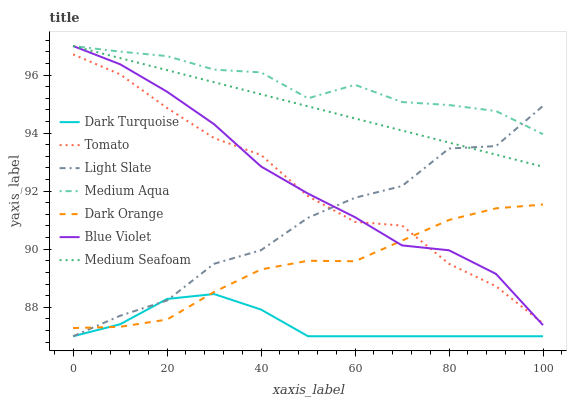Does Dark Turquoise have the minimum area under the curve?
Answer yes or no. Yes. Does Medium Aqua have the maximum area under the curve?
Answer yes or no. Yes. Does Dark Orange have the minimum area under the curve?
Answer yes or no. No. Does Dark Orange have the maximum area under the curve?
Answer yes or no. No. Is Medium Seafoam the smoothest?
Answer yes or no. Yes. Is Light Slate the roughest?
Answer yes or no. Yes. Is Dark Orange the smoothest?
Answer yes or no. No. Is Dark Orange the roughest?
Answer yes or no. No. Does Dark Orange have the lowest value?
Answer yes or no. No. Does Blue Violet have the highest value?
Answer yes or no. Yes. Does Dark Orange have the highest value?
Answer yes or no. No. Is Dark Orange less than Medium Seafoam?
Answer yes or no. Yes. Is Medium Seafoam greater than Dark Turquoise?
Answer yes or no. Yes. Does Light Slate intersect Dark Turquoise?
Answer yes or no. Yes. Is Light Slate less than Dark Turquoise?
Answer yes or no. No. Is Light Slate greater than Dark Turquoise?
Answer yes or no. No. Does Dark Orange intersect Medium Seafoam?
Answer yes or no. No. 